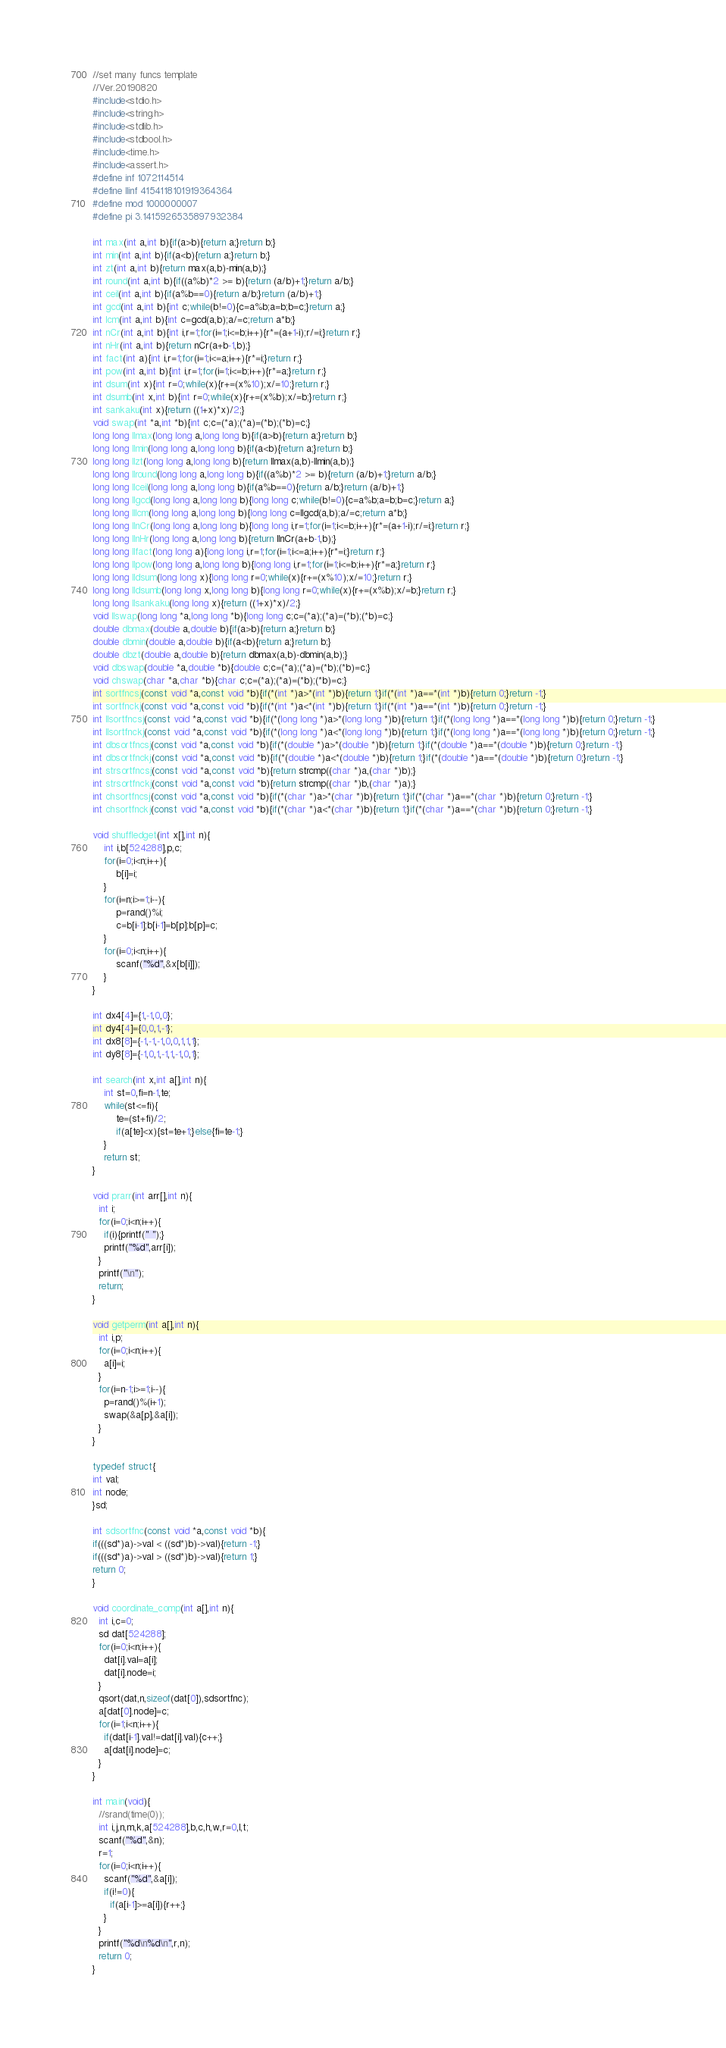Convert code to text. <code><loc_0><loc_0><loc_500><loc_500><_C_>//set many funcs template
//Ver.20190820
#include<stdio.h>
#include<string.h>
#include<stdlib.h>
#include<stdbool.h>
#include<time.h>
#include<assert.h>
#define inf 1072114514
#define llinf 4154118101919364364
#define mod 1000000007
#define pi 3.1415926535897932384

int max(int a,int b){if(a>b){return a;}return b;}
int min(int a,int b){if(a<b){return a;}return b;}
int zt(int a,int b){return max(a,b)-min(a,b);}
int round(int a,int b){if((a%b)*2 >= b){return (a/b)+1;}return a/b;}
int ceil(int a,int b){if(a%b==0){return a/b;}return (a/b)+1;}
int gcd(int a,int b){int c;while(b!=0){c=a%b;a=b;b=c;}return a;}
int lcm(int a,int b){int c=gcd(a,b);a/=c;return a*b;}
int nCr(int a,int b){int i,r=1;for(i=1;i<=b;i++){r*=(a+1-i);r/=i;}return r;}
int nHr(int a,int b){return nCr(a+b-1,b);}
int fact(int a){int i,r=1;for(i=1;i<=a;i++){r*=i;}return r;}
int pow(int a,int b){int i,r=1;for(i=1;i<=b;i++){r*=a;}return r;}
int dsum(int x){int r=0;while(x){r+=(x%10);x/=10;}return r;}
int dsumb(int x,int b){int r=0;while(x){r+=(x%b);x/=b;}return r;}
int sankaku(int x){return ((1+x)*x)/2;}
void swap(int *a,int *b){int c;c=(*a);(*a)=(*b);(*b)=c;}
long long llmax(long long a,long long b){if(a>b){return a;}return b;}
long long llmin(long long a,long long b){if(a<b){return a;}return b;}
long long llzt(long long a,long long b){return llmax(a,b)-llmin(a,b);}
long long llround(long long a,long long b){if((a%b)*2 >= b){return (a/b)+1;}return a/b;}
long long llceil(long long a,long long b){if(a%b==0){return a/b;}return (a/b)+1;}
long long llgcd(long long a,long long b){long long c;while(b!=0){c=a%b;a=b;b=c;}return a;}
long long lllcm(long long a,long long b){long long c=llgcd(a,b);a/=c;return a*b;}
long long llnCr(long long a,long long b){long long i,r=1;for(i=1;i<=b;i++){r*=(a+1-i);r/=i;}return r;}
long long llnHr(long long a,long long b){return llnCr(a+b-1,b);}
long long llfact(long long a){long long i,r=1;for(i=1;i<=a;i++){r*=i;}return r;}
long long llpow(long long a,long long b){long long i,r=1;for(i=1;i<=b;i++){r*=a;}return r;}
long long lldsum(long long x){long long r=0;while(x){r+=(x%10);x/=10;}return r;}
long long lldsumb(long long x,long long b){long long r=0;while(x){r+=(x%b);x/=b;}return r;}
long long llsankaku(long long x){return ((1+x)*x)/2;}
void llswap(long long *a,long long *b){long long c;c=(*a);(*a)=(*b);(*b)=c;}
double dbmax(double a,double b){if(a>b){return a;}return b;}
double dbmin(double a,double b){if(a<b){return a;}return b;}
double dbzt(double a,double b){return dbmax(a,b)-dbmin(a,b);}
void dbswap(double *a,double *b){double c;c=(*a);(*a)=(*b);(*b)=c;}
void chswap(char *a,char *b){char c;c=(*a);(*a)=(*b);(*b)=c;}
int sortfncsj(const void *a,const void *b){if(*(int *)a>*(int *)b){return 1;}if(*(int *)a==*(int *)b){return 0;}return -1;}
int sortfnckj(const void *a,const void *b){if(*(int *)a<*(int *)b){return 1;}if(*(int *)a==*(int *)b){return 0;}return -1;}
int llsortfncsj(const void *a,const void *b){if(*(long long *)a>*(long long *)b){return 1;}if(*(long long *)a==*(long long *)b){return 0;}return -1;}
int llsortfnckj(const void *a,const void *b){if(*(long long *)a<*(long long *)b){return 1;}if(*(long long *)a==*(long long *)b){return 0;}return -1;}
int dbsortfncsj(const void *a,const void *b){if(*(double *)a>*(double *)b){return 1;}if(*(double *)a==*(double *)b){return 0;}return -1;}
int dbsortfnckj(const void *a,const void *b){if(*(double *)a<*(double *)b){return 1;}if(*(double *)a==*(double *)b){return 0;}return -1;}
int strsortfncsj(const void *a,const void *b){return strcmp((char *)a,(char *)b);}
int strsortfnckj(const void *a,const void *b){return strcmp((char *)b,(char *)a);}
int chsortfncsj(const void *a,const void *b){if(*(char *)a>*(char *)b){return 1;}if(*(char *)a==*(char *)b){return 0;}return -1;}
int chsortfnckj(const void *a,const void *b){if(*(char *)a<*(char *)b){return 1;}if(*(char *)a==*(char *)b){return 0;}return -1;}

void shuffledget(int x[],int n){
    int i,b[524288],p,c;
    for(i=0;i<n;i++){
        b[i]=i;
    }
    for(i=n;i>=1;i--){
        p=rand()%i;
        c=b[i-1];b[i-1]=b[p];b[p]=c;
    }
    for(i=0;i<n;i++){
        scanf("%d",&x[b[i]]);
    }
}

int dx4[4]={1,-1,0,0};
int dy4[4]={0,0,1,-1};
int dx8[8]={-1,-1,-1,0,0,1,1,1};
int dy8[8]={-1,0,1,-1,1,-1,0,1};

int search(int x,int a[],int n){
    int st=0,fi=n-1,te;
    while(st<=fi){
        te=(st+fi)/2;
        if(a[te]<x){st=te+1;}else{fi=te-1;}
    }
    return st;
}

void prarr(int arr[],int n){
  int i;
  for(i=0;i<n;i++){
    if(i){printf(" ");}
    printf("%d",arr[i]);
  }
  printf("\n");
  return;
}

void getperm(int a[],int n){
  int i,p;
  for(i=0;i<n;i++){
    a[i]=i;
  }
  for(i=n-1;i>=1;i--){
    p=rand()%(i+1);
    swap(&a[p],&a[i]);
  }
}

typedef struct{
int val;
int node;
}sd;

int sdsortfnc(const void *a,const void *b){
if(((sd*)a)->val < ((sd*)b)->val){return -1;}
if(((sd*)a)->val > ((sd*)b)->val){return 1;}
return 0;
}

void coordinate_comp(int a[],int n){
  int i,c=0;
  sd dat[524288];
  for(i=0;i<n;i++){
    dat[i].val=a[i];
    dat[i].node=i;
  }
  qsort(dat,n,sizeof(dat[0]),sdsortfnc);
  a[dat[0].node]=c;
  for(i=1;i<n;i++){
    if(dat[i-1].val!=dat[i].val){c++;}
    a[dat[i].node]=c;
  }
}

int main(void){
  //srand(time(0));
  int i,j,n,m,k,a[524288],b,c,h,w,r=0,l,t;
  scanf("%d",&n);
  r=1;
  for(i=0;i<n;i++){
    scanf("%d",&a[i]);
    if(i!=0){
      if(a[i-1]>=a[i]){r++;}
    }
  }
  printf("%d\n%d\n",r,n);
  return 0;
}

</code> 